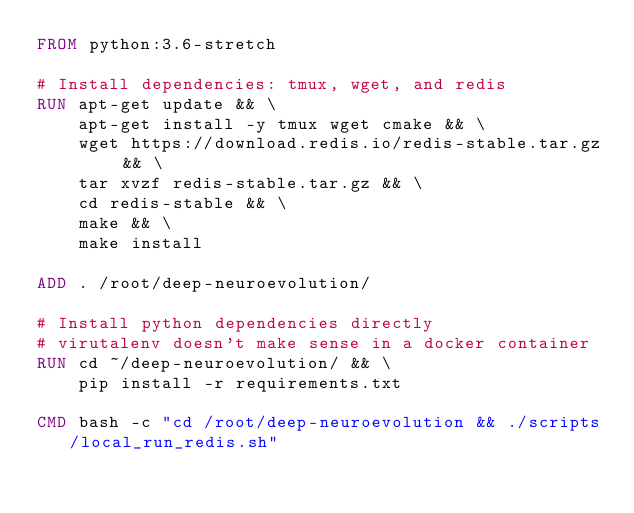Convert code to text. <code><loc_0><loc_0><loc_500><loc_500><_Dockerfile_>FROM python:3.6-stretch

# Install dependencies: tmux, wget, and redis
RUN apt-get update && \
    apt-get install -y tmux wget cmake && \
    wget https://download.redis.io/redis-stable.tar.gz && \
    tar xvzf redis-stable.tar.gz && \
    cd redis-stable && \
    make && \
    make install

ADD . /root/deep-neuroevolution/

# Install python dependencies directly
# virutalenv doesn't make sense in a docker container 
RUN cd ~/deep-neuroevolution/ && \
    pip install -r requirements.txt

CMD bash -c "cd /root/deep-neuroevolution && ./scripts/local_run_redis.sh"


</code> 